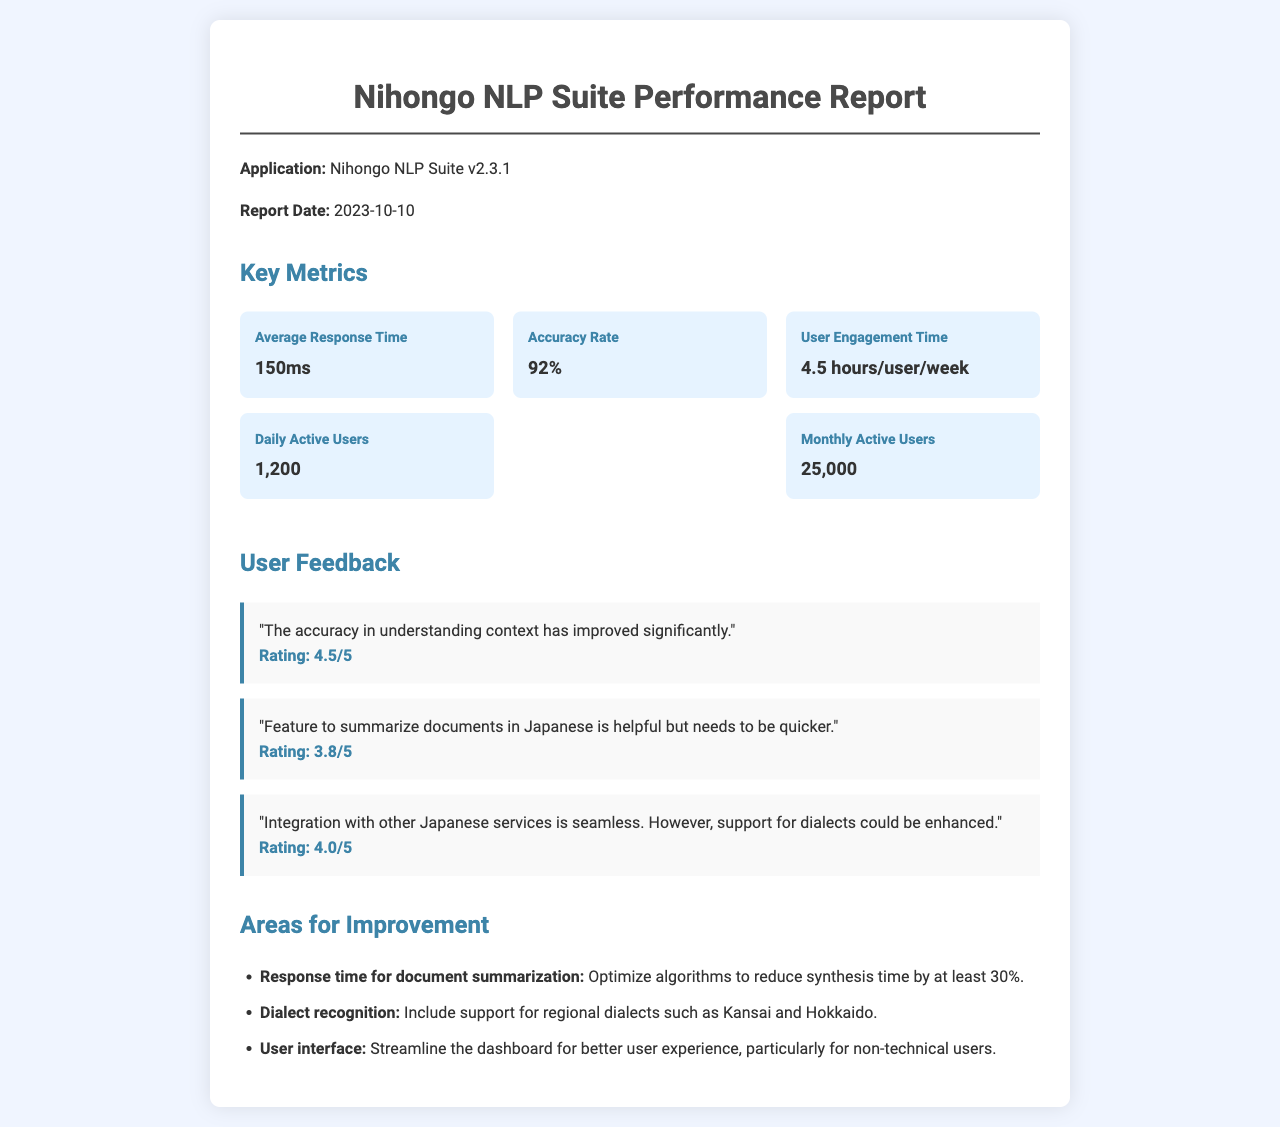What is the version of the application? The version of the application is explicitly stated in the report.
Answer: v2.3.1 What is the report date? The report date is mentioned clearly in the document.
Answer: 2023-10-10 What is the accuracy rate of the application? The accuracy rate is one of the key metrics outlined in the performance report.
Answer: 92% How many daily active users does the application have? The number of daily active users is specifically provided in the metrics section.
Answer: 1,200 What is the user engagement time per week? The user engagement time is described in hours per user per week.
Answer: 4.5 hours/user/week What is a feature that users find helpful? User feedback mentions particular features that they appreciate.
Answer: Summarize documents in Japanese What aspect of the application does user feedback suggest needs improvement? Feedback indicates specific areas where users believe the application could be enhanced.
Answer: Quicker summarization How many monthly active users are there? The figure for monthly active users is noted under key metrics.
Answer: 25,000 What is one area for improvement regarding dialect recognition? The improvement areas detail specific dialects that need support.
Answer: Kansai and Hokkaido 